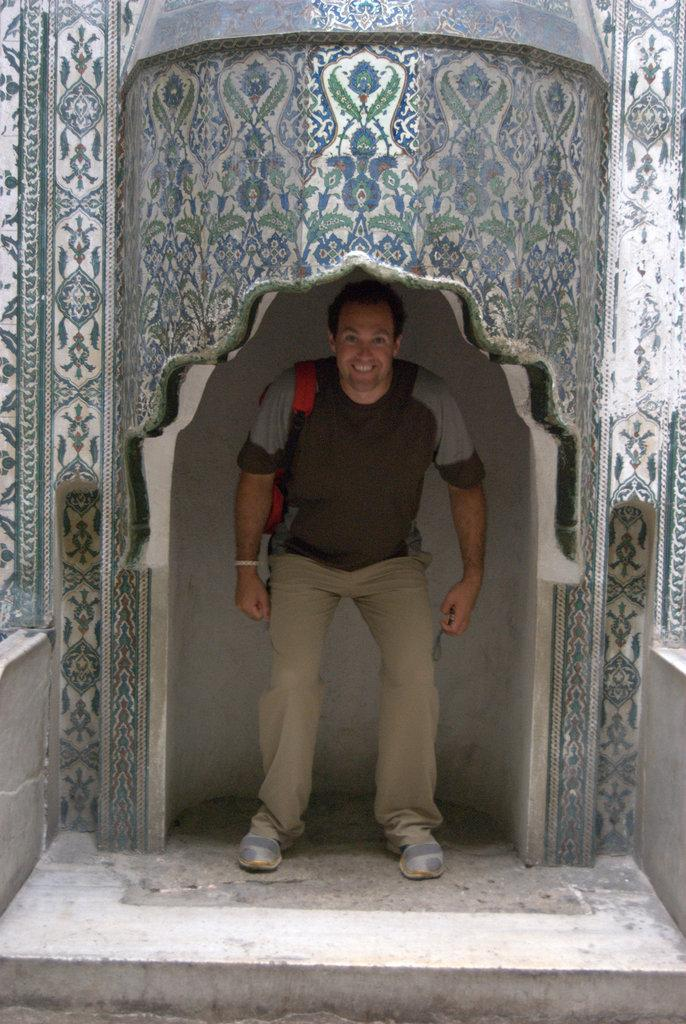Who is the main subject in the image? There is a man standing in the center of the image. What is the man holding or carrying in the image? The man is carrying a bag. What architectural feature can be seen at the top of the image? There is an arch at the top of the image. What is visible at the bottom of the image? The ground is visible at the bottom of the image. Can you see a monkey climbing on the arch in the image? There is no monkey present in the image; it only features a man standing in the center and an arch at the top. 